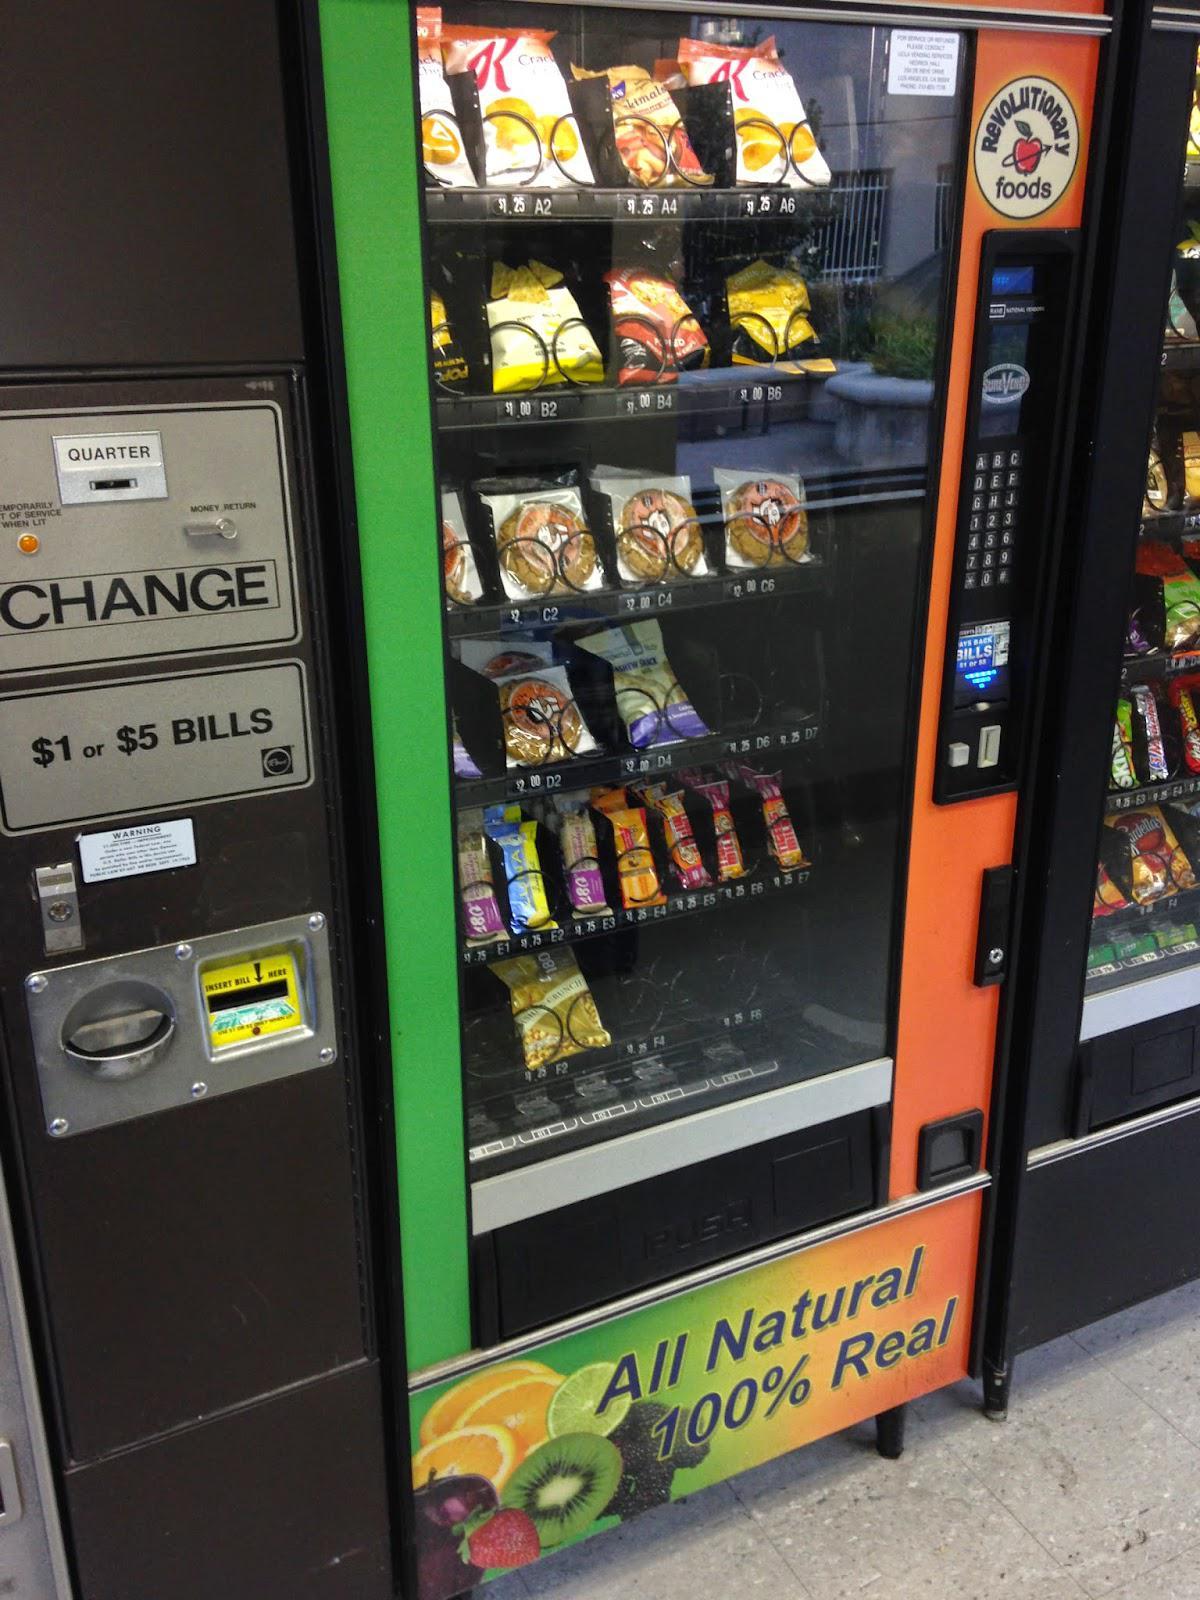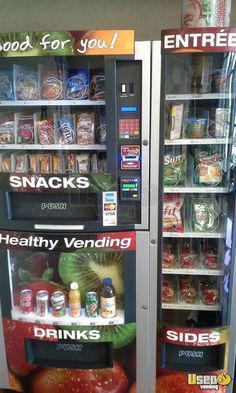The first image is the image on the left, the second image is the image on the right. Examine the images to the left and right. Is the description "There are at least three vending machines that have food or drinks." accurate? Answer yes or no. Yes. 